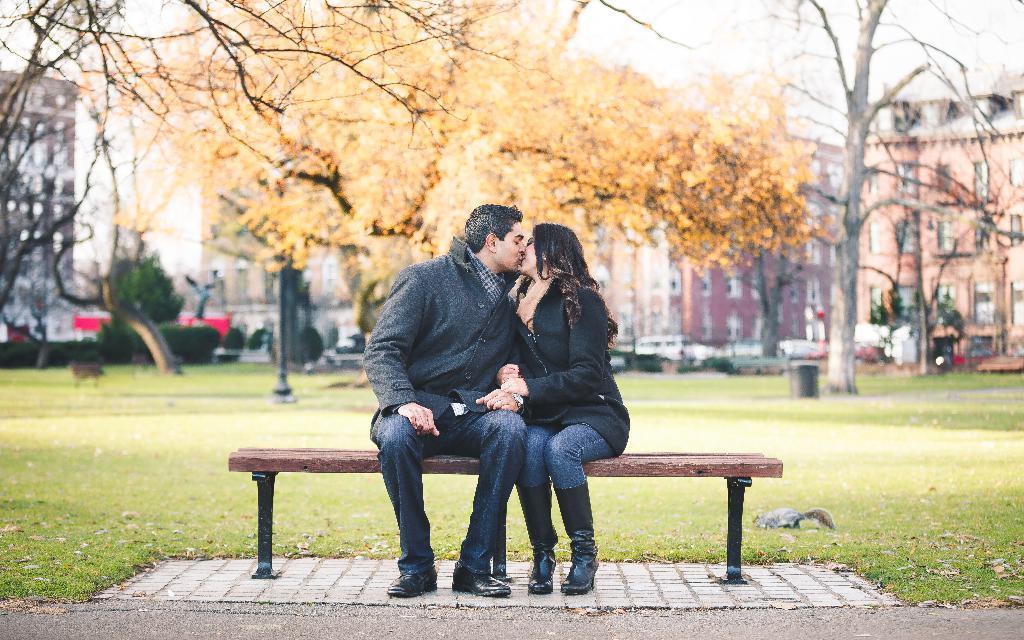Can you describe this image briefly? These Two persons sitting on the bench and kissing each other. On the background we can see grass,pole,trees,Buildings. 